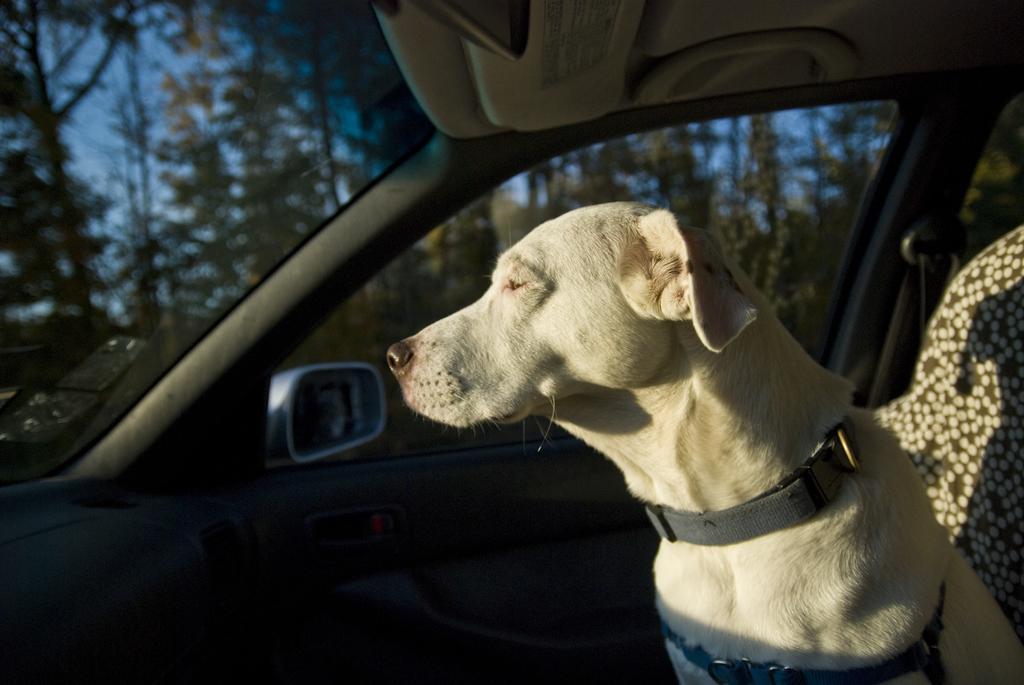Can you describe this image briefly? In the image we can see there is a dog sitting in the car. 